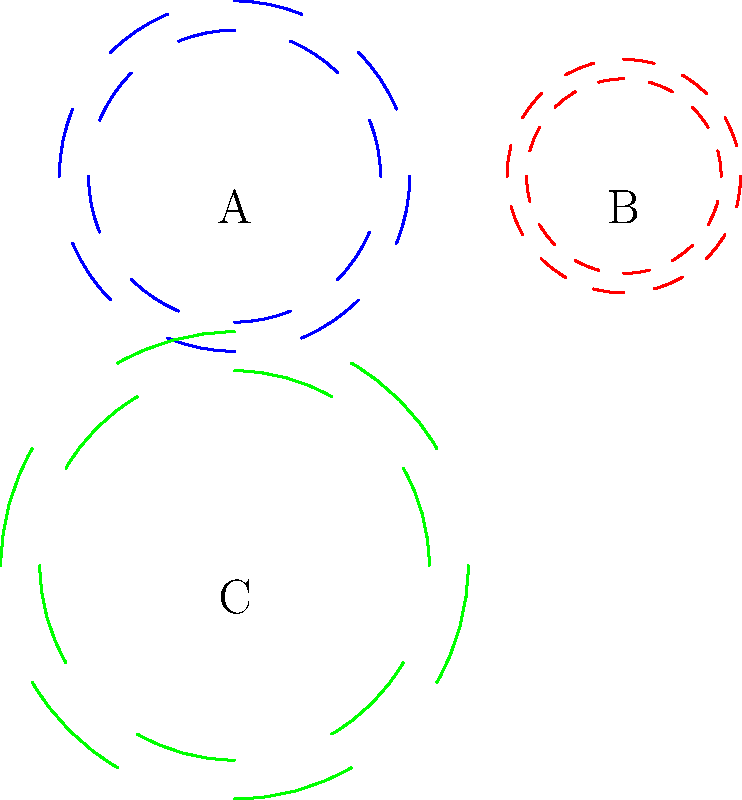In your favorite telenovela, the handsome mechanic is explaining different types of gears to the protagonist. Looking at the image, which gear would be best suited for high-speed, low-torque applications in the mechanic's workshop? To answer this question, we need to consider the characteristics of each gear shown in the image:

1. Gear A (blue):
   - Medium-sized gear
   - 8 teeth
   - Moderate speed and torque capabilities

2. Gear B (red):
   - Smallest gear
   - 12 teeth
   - Highest speed, lowest torque

3. Gear C (green):
   - Largest gear
   - 6 teeth
   - Lowest speed, highest torque

In mechanical engineering, the relationship between gear size, number of teeth, speed, and torque is as follows:

- Smaller gears with more teeth rotate faster but produce less torque.
- Larger gears with fewer teeth rotate slower but produce more torque.

For high-speed, low-torque applications, we want a gear that can rotate quickly while not requiring a lot of force. This description best fits Gear B, which is the smallest gear with the most teeth.

In the context of a telenovela, the mechanic might explain that this type of gear would be perfect for applications like small electric motors or high-speed drills used in delicate repair work.
Answer: Gear B (red) 